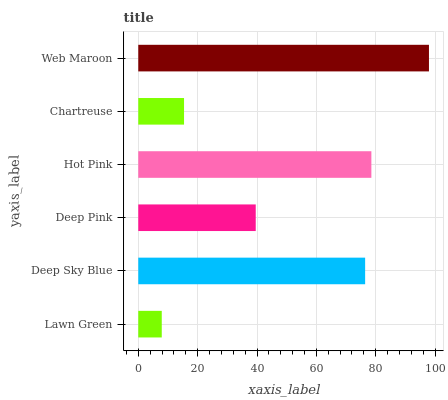Is Lawn Green the minimum?
Answer yes or no. Yes. Is Web Maroon the maximum?
Answer yes or no. Yes. Is Deep Sky Blue the minimum?
Answer yes or no. No. Is Deep Sky Blue the maximum?
Answer yes or no. No. Is Deep Sky Blue greater than Lawn Green?
Answer yes or no. Yes. Is Lawn Green less than Deep Sky Blue?
Answer yes or no. Yes. Is Lawn Green greater than Deep Sky Blue?
Answer yes or no. No. Is Deep Sky Blue less than Lawn Green?
Answer yes or no. No. Is Deep Sky Blue the high median?
Answer yes or no. Yes. Is Deep Pink the low median?
Answer yes or no. Yes. Is Chartreuse the high median?
Answer yes or no. No. Is Lawn Green the low median?
Answer yes or no. No. 